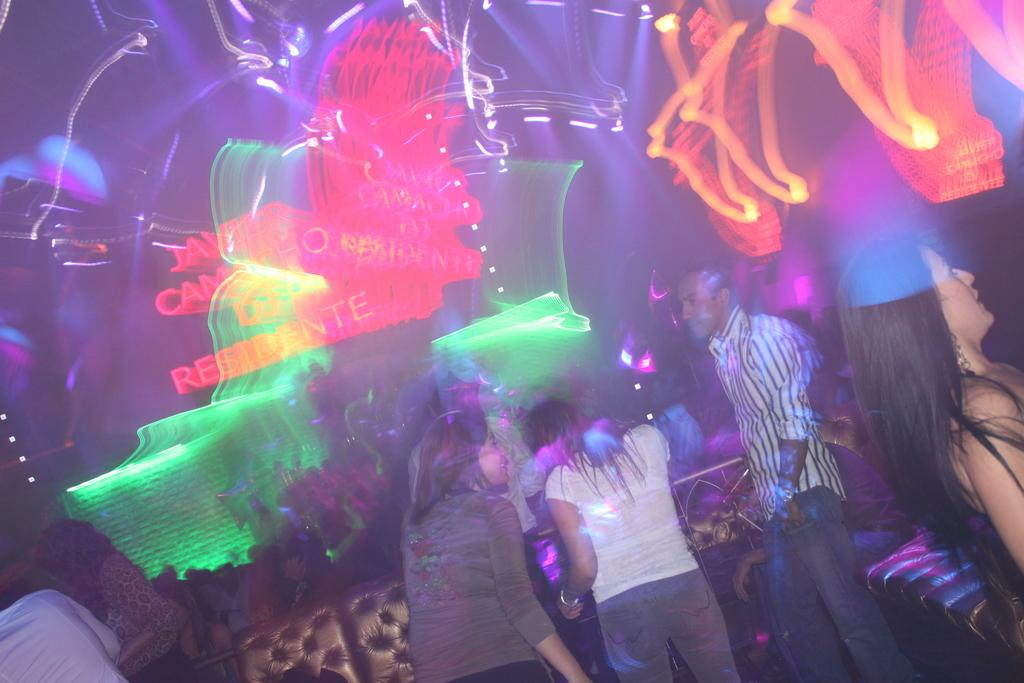Who or what is present in the image? There are people in the image. What are the people sitting on in the image? There are seats in the image. What type of lighting is present in the image? There are electric lights in the image. Are there any spiders crawling on the people in the image? There is no indication of spiders or any crawling creatures in the image. 